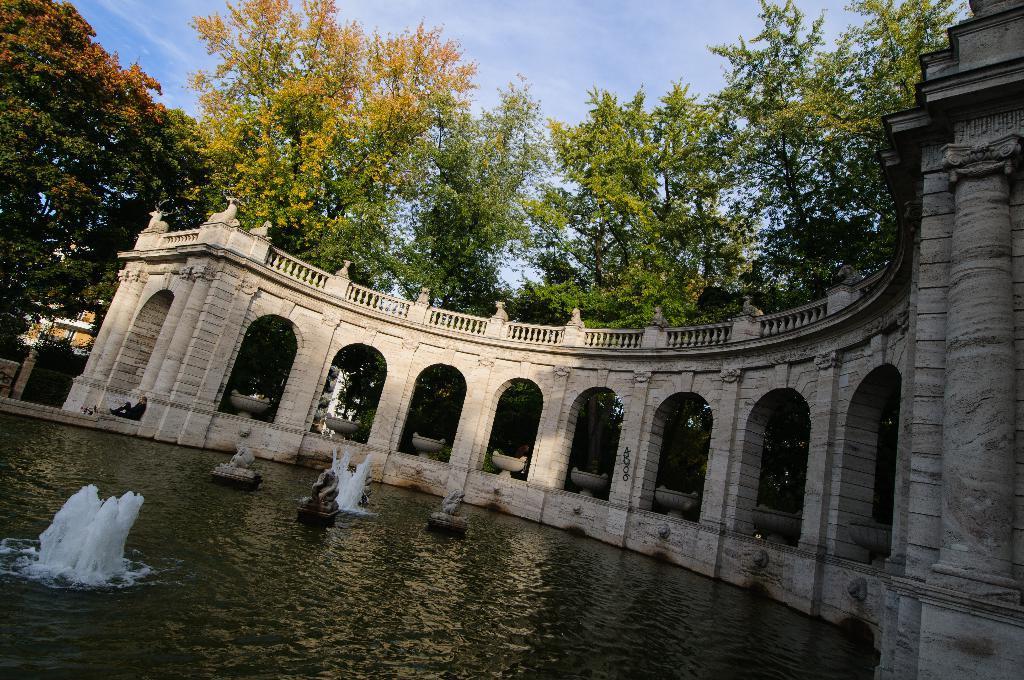In one or two sentences, can you explain what this image depicts? In this image in the center there is a building and at the bottom there is fountain, and also we could see some statues and one person is sitting. In the background there are some trees and houses, at the top of the image there is sky. 